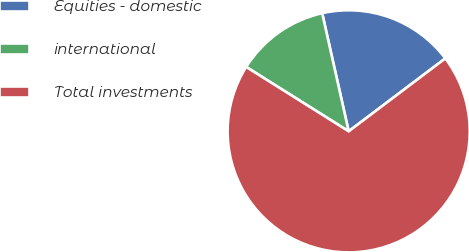<chart> <loc_0><loc_0><loc_500><loc_500><pie_chart><fcel>Equities - domestic<fcel>international<fcel>Total investments<nl><fcel>18.23%<fcel>12.56%<fcel>69.21%<nl></chart> 